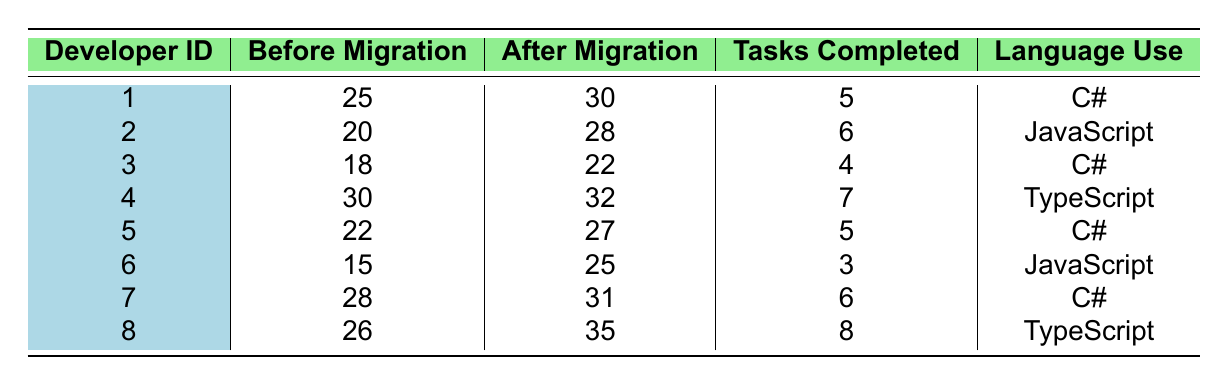What is the productivity increase of Developer ID 6 after migration? Developer ID 6 had a productivity of 15 before migration and 25 after migration. The increase is calculated as 25 - 15 = 10.
Answer: 10 What language does Developer ID 4 use? The table shows that Developer ID 4 uses TypeScript.
Answer: TypeScript Which developer has the highest number of tasks completed after migration? Looking through the Tasks Completed column after migration, Developer ID 8 completed 8 tasks, which is the highest among all.
Answer: Developer ID 8 What is the average increase in productivity across all developers? To find the average increase, calculate each developer's increase: (30-25) + (28-20) + (22-18) + (32-30) + (27-22) + (25-15) + (31-28) + (35-26) = 5 + 8 + 4 + 2 + 5 + 10 + 3 + 9 = 46. There are 8 developers, so the average increase is 46/8 = 5.75.
Answer: 5.75 Does any developer use JavaScript after migration? The table indicates that Developer ID 2 and Developer ID 6 both work with JavaScript. Therefore, the answer is yes.
Answer: Yes Which developer had the least productivity before migration? The data shows that Developer ID 6 had the lowest productivity at 15 before migration compared to the others listed.
Answer: Developer ID 6 What is the difference in the number of tasks completed between Developer ID 1 and Developer ID 5 after migration? Developer ID 1 completed 5 tasks and Developer ID 5 completed 5 tasks after migration. The difference is 5 - 5 = 0.
Answer: 0 How many developers showed an increase in productivity after migration? By checking the "After Migration" column and comparing it to "Before Migration," all developers had higher productivity after migration. There are 8 developers in total.
Answer: 8 